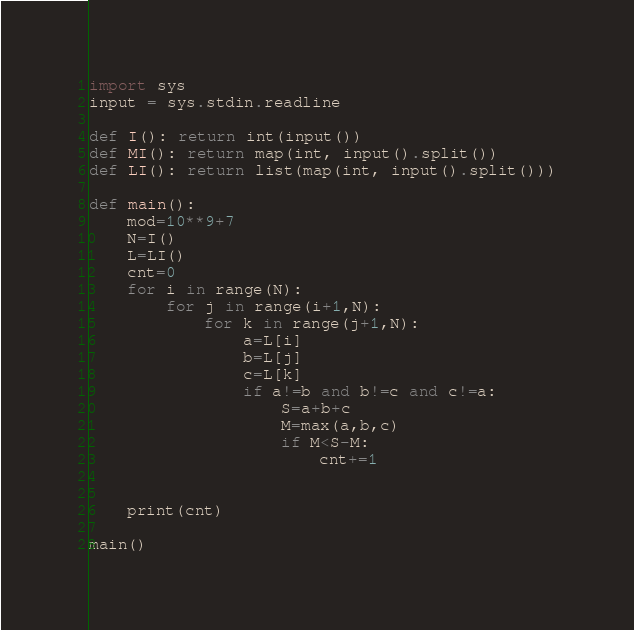Convert code to text. <code><loc_0><loc_0><loc_500><loc_500><_Python_>import sys
input = sys.stdin.readline

def I(): return int(input())
def MI(): return map(int, input().split())
def LI(): return list(map(int, input().split()))

def main():
    mod=10**9+7
    N=I()
    L=LI()
    cnt=0
    for i in range(N):
        for j in range(i+1,N):
            for k in range(j+1,N):
                a=L[i]
                b=L[j]
                c=L[k]
                if a!=b and b!=c and c!=a:
                    S=a+b+c
                    M=max(a,b,c)
                    if M<S-M:
                        cnt+=1
                    
                    
    print(cnt)

main()
</code> 